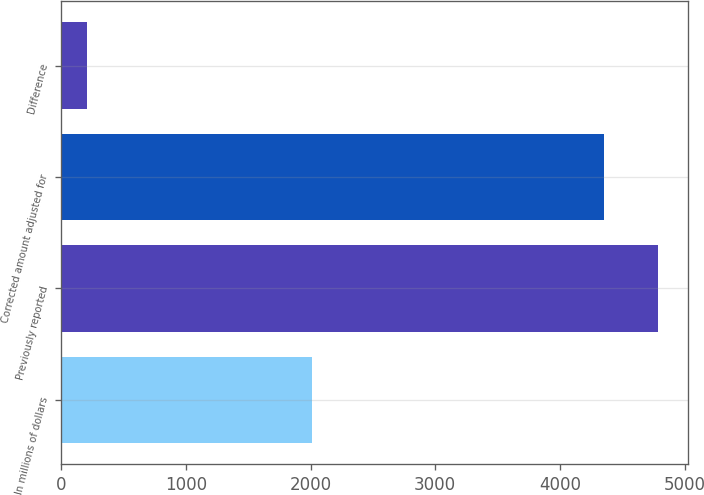Convert chart to OTSL. <chart><loc_0><loc_0><loc_500><loc_500><bar_chart><fcel>In millions of dollars<fcel>Previously reported<fcel>Corrected amount adjusted for<fcel>Difference<nl><fcel>2008<fcel>4787.2<fcel>4352<fcel>206<nl></chart> 